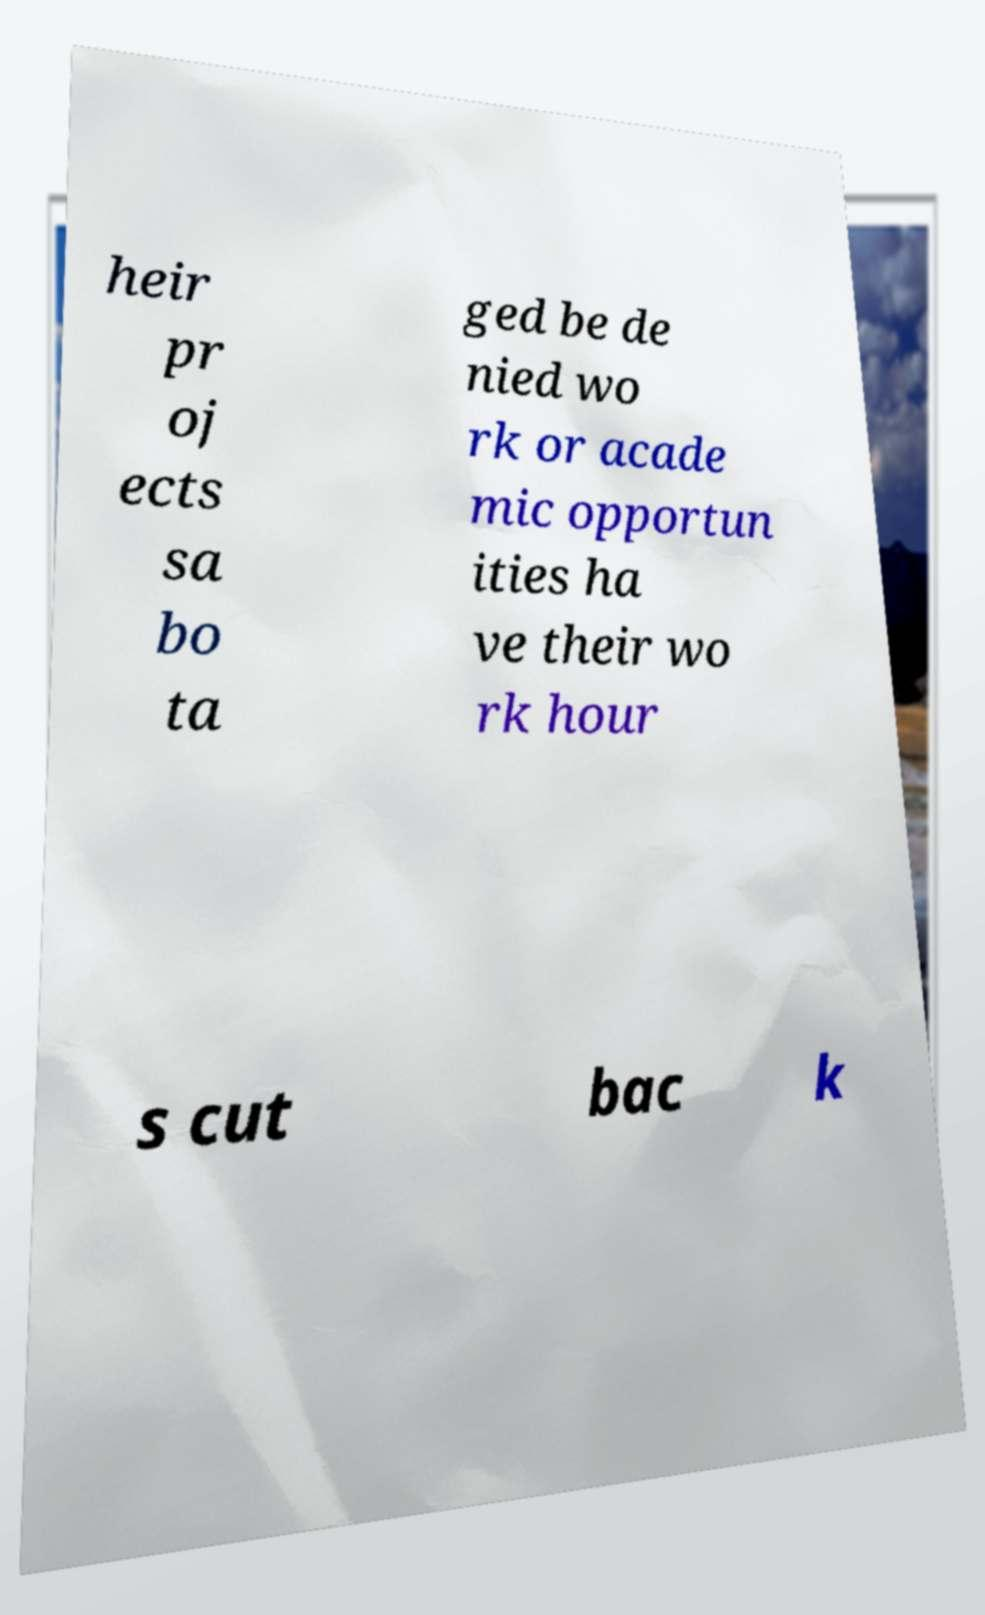What messages or text are displayed in this image? I need them in a readable, typed format. heir pr oj ects sa bo ta ged be de nied wo rk or acade mic opportun ities ha ve their wo rk hour s cut bac k 